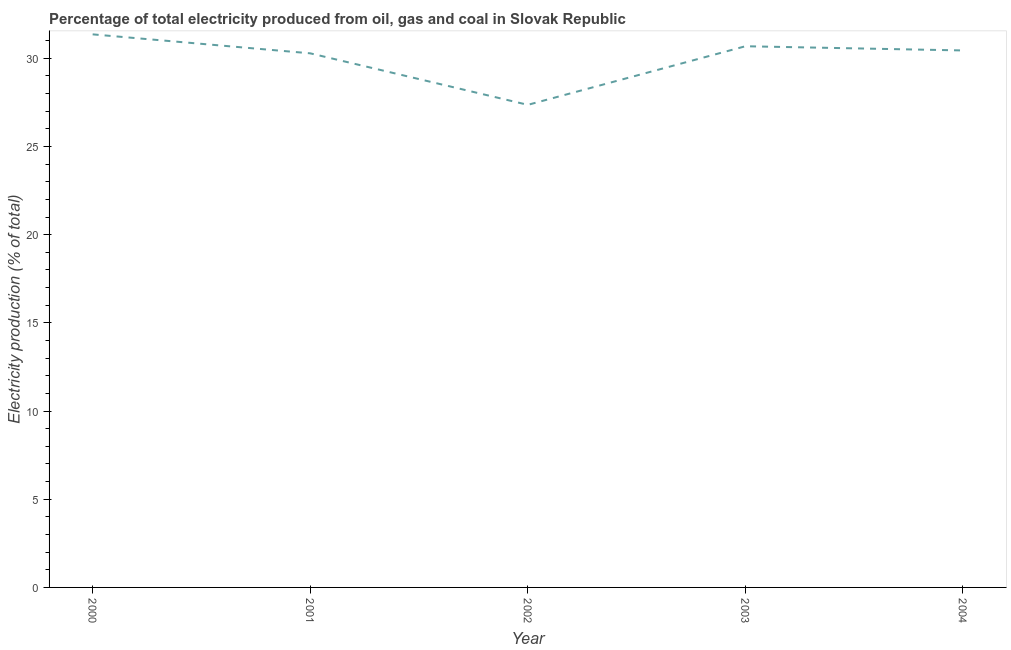What is the electricity production in 2003?
Keep it short and to the point. 30.68. Across all years, what is the maximum electricity production?
Offer a terse response. 31.36. Across all years, what is the minimum electricity production?
Your response must be concise. 27.36. In which year was the electricity production maximum?
Keep it short and to the point. 2000. What is the sum of the electricity production?
Ensure brevity in your answer.  150.12. What is the difference between the electricity production in 2000 and 2003?
Your answer should be compact. 0.67. What is the average electricity production per year?
Make the answer very short. 30.02. What is the median electricity production?
Ensure brevity in your answer.  30.44. In how many years, is the electricity production greater than 16 %?
Your answer should be very brief. 5. Do a majority of the years between 2004 and 2003 (inclusive) have electricity production greater than 4 %?
Make the answer very short. No. What is the ratio of the electricity production in 2000 to that in 2001?
Your answer should be very brief. 1.04. Is the electricity production in 2000 less than that in 2003?
Make the answer very short. No. Is the difference between the electricity production in 2000 and 2002 greater than the difference between any two years?
Your answer should be compact. Yes. What is the difference between the highest and the second highest electricity production?
Your response must be concise. 0.67. Is the sum of the electricity production in 2001 and 2003 greater than the maximum electricity production across all years?
Your response must be concise. Yes. What is the difference between the highest and the lowest electricity production?
Offer a very short reply. 4. In how many years, is the electricity production greater than the average electricity production taken over all years?
Offer a terse response. 4. How many years are there in the graph?
Offer a terse response. 5. Does the graph contain any zero values?
Offer a terse response. No. Does the graph contain grids?
Make the answer very short. No. What is the title of the graph?
Your answer should be compact. Percentage of total electricity produced from oil, gas and coal in Slovak Republic. What is the label or title of the X-axis?
Keep it short and to the point. Year. What is the label or title of the Y-axis?
Ensure brevity in your answer.  Electricity production (% of total). What is the Electricity production (% of total) of 2000?
Your answer should be compact. 31.36. What is the Electricity production (% of total) of 2001?
Offer a very short reply. 30.28. What is the Electricity production (% of total) in 2002?
Your answer should be very brief. 27.36. What is the Electricity production (% of total) of 2003?
Make the answer very short. 30.68. What is the Electricity production (% of total) in 2004?
Give a very brief answer. 30.44. What is the difference between the Electricity production (% of total) in 2000 and 2001?
Your response must be concise. 1.08. What is the difference between the Electricity production (% of total) in 2000 and 2002?
Your answer should be compact. 4. What is the difference between the Electricity production (% of total) in 2000 and 2003?
Your answer should be very brief. 0.67. What is the difference between the Electricity production (% of total) in 2000 and 2004?
Give a very brief answer. 0.91. What is the difference between the Electricity production (% of total) in 2001 and 2002?
Provide a succinct answer. 2.92. What is the difference between the Electricity production (% of total) in 2001 and 2003?
Provide a succinct answer. -0.4. What is the difference between the Electricity production (% of total) in 2001 and 2004?
Provide a short and direct response. -0.16. What is the difference between the Electricity production (% of total) in 2002 and 2003?
Your answer should be compact. -3.32. What is the difference between the Electricity production (% of total) in 2002 and 2004?
Your answer should be compact. -3.08. What is the difference between the Electricity production (% of total) in 2003 and 2004?
Offer a very short reply. 0.24. What is the ratio of the Electricity production (% of total) in 2000 to that in 2001?
Keep it short and to the point. 1.04. What is the ratio of the Electricity production (% of total) in 2000 to that in 2002?
Ensure brevity in your answer.  1.15. What is the ratio of the Electricity production (% of total) in 2000 to that in 2003?
Provide a short and direct response. 1.02. What is the ratio of the Electricity production (% of total) in 2001 to that in 2002?
Your response must be concise. 1.11. What is the ratio of the Electricity production (% of total) in 2001 to that in 2003?
Your answer should be very brief. 0.99. What is the ratio of the Electricity production (% of total) in 2001 to that in 2004?
Ensure brevity in your answer.  0.99. What is the ratio of the Electricity production (% of total) in 2002 to that in 2003?
Keep it short and to the point. 0.89. What is the ratio of the Electricity production (% of total) in 2002 to that in 2004?
Ensure brevity in your answer.  0.9. What is the ratio of the Electricity production (% of total) in 2003 to that in 2004?
Offer a very short reply. 1.01. 